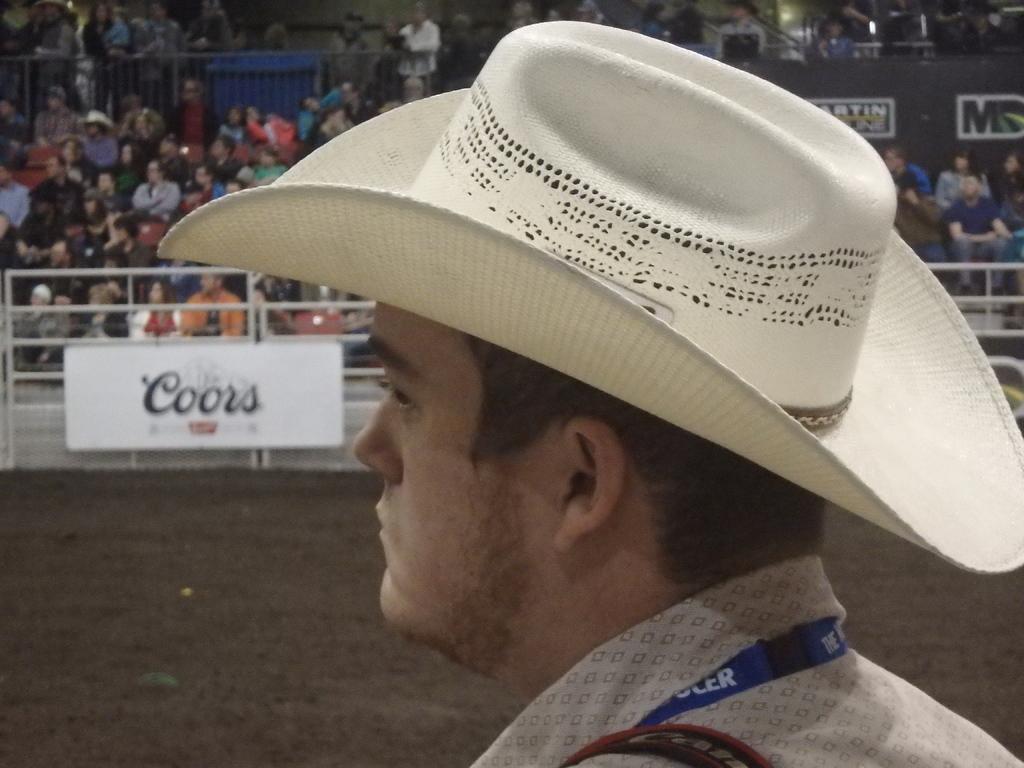Could you give a brief overview of what you see in this image? In the center of the image we can see one person standing and he is wearing a hat. In the background, we can see the fences, banners, few people are sitting, few people are standing and a few other objects. 